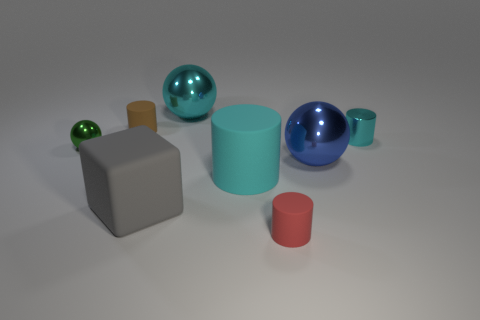There is a large cube that is the same material as the red object; what is its color?
Keep it short and to the point. Gray. Is the color of the small metallic cylinder the same as the large metal thing on the left side of the large cyan cylinder?
Give a very brief answer. Yes. Are there any cyan cylinders that are right of the small metallic object that is on the left side of the big gray matte block that is on the left side of the cyan metal cylinder?
Keep it short and to the point. Yes. What shape is the large gray thing that is made of the same material as the brown cylinder?
Keep it short and to the point. Cube. Are there any other things that are the same shape as the large gray rubber thing?
Make the answer very short. No. The gray thing has what shape?
Keep it short and to the point. Cube. Do the matte thing on the right side of the cyan rubber thing and the brown object have the same shape?
Keep it short and to the point. Yes. Is the number of big cyan rubber cylinders to the right of the red object greater than the number of big cyan cylinders that are in front of the big matte block?
Give a very brief answer. No. What number of other objects are there of the same size as the green thing?
Give a very brief answer. 3. There is a large cyan metal thing; is it the same shape as the tiny metallic object that is left of the gray matte cube?
Make the answer very short. Yes. 